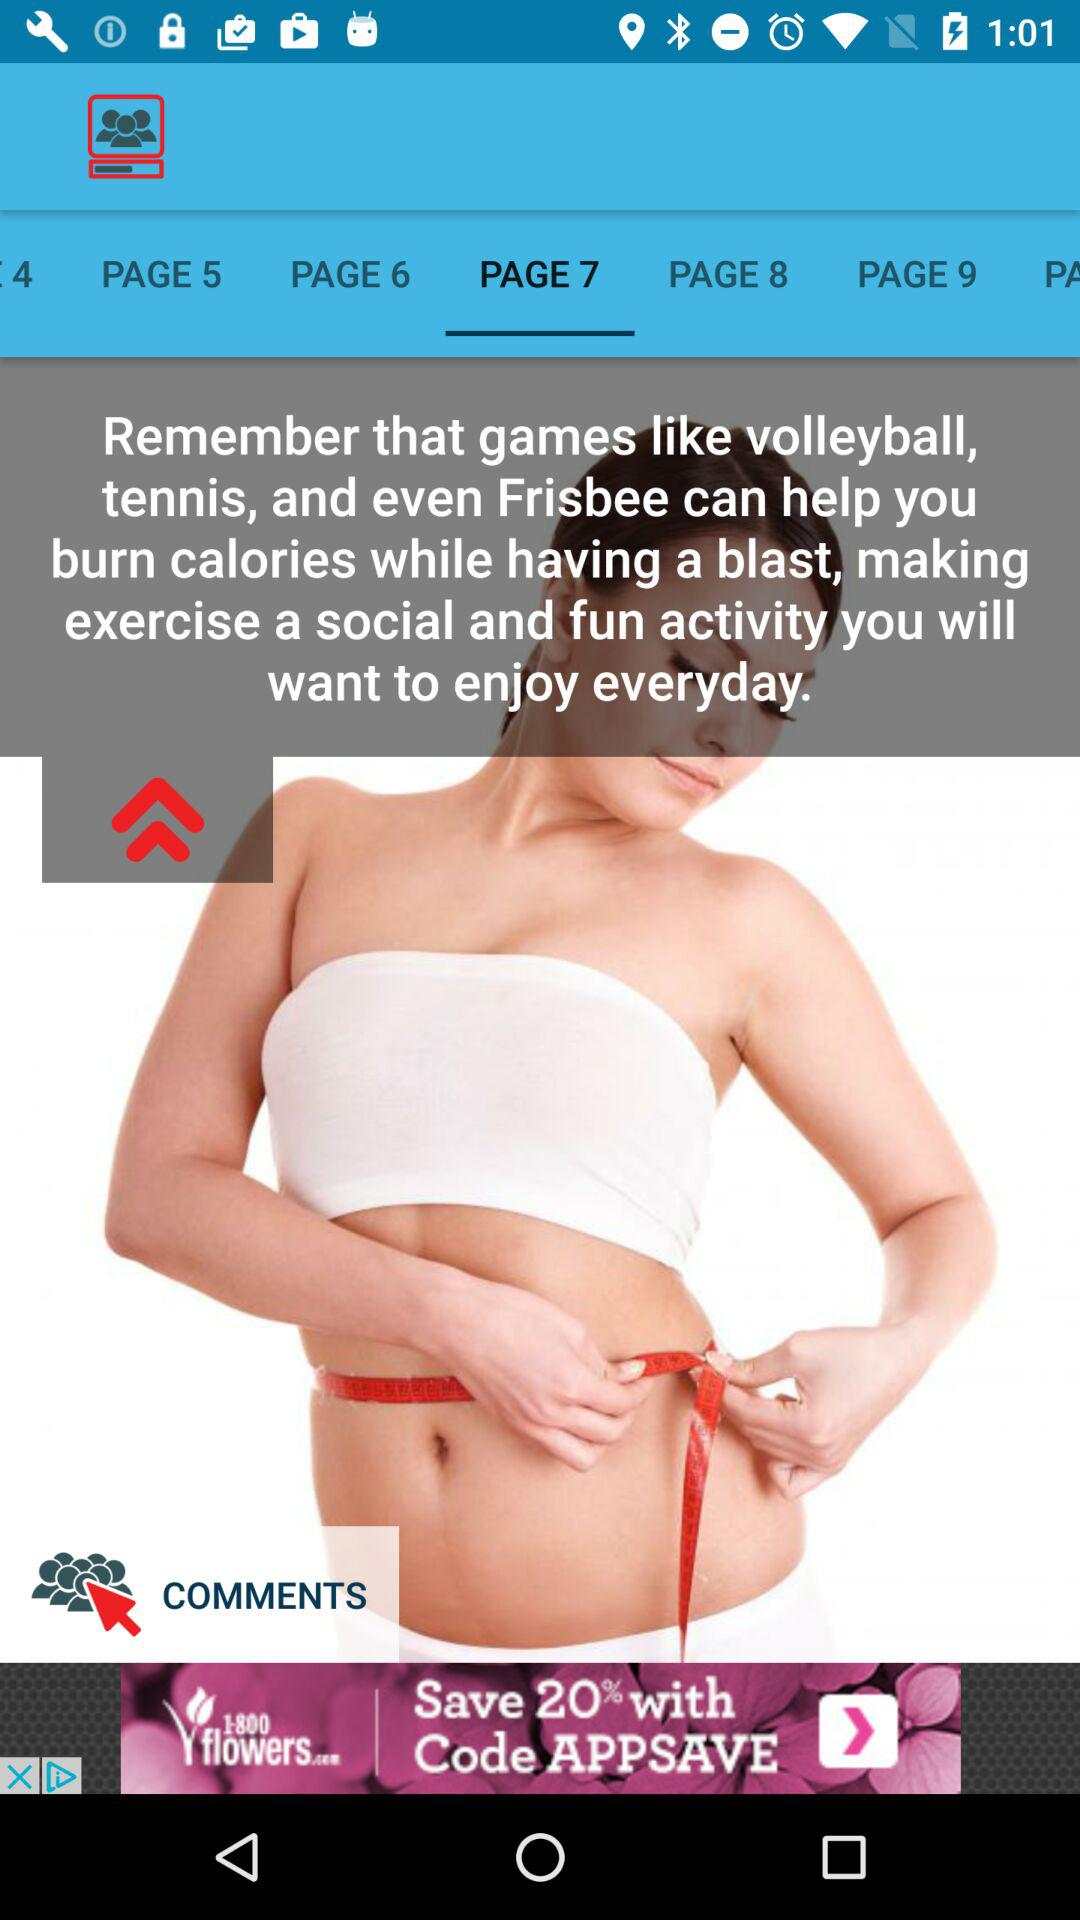Which is the selected tab? The selected tab is "PAGE 7". 